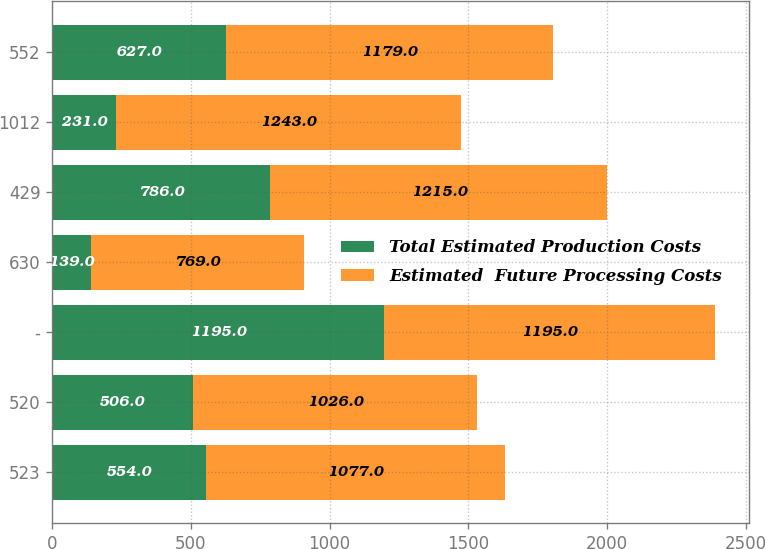<chart> <loc_0><loc_0><loc_500><loc_500><stacked_bar_chart><ecel><fcel>523<fcel>520<fcel>-<fcel>630<fcel>429<fcel>1012<fcel>552<nl><fcel>Total Estimated Production Costs<fcel>554<fcel>506<fcel>1195<fcel>139<fcel>786<fcel>231<fcel>627<nl><fcel>Estimated  Future Processing Costs<fcel>1077<fcel>1026<fcel>1195<fcel>769<fcel>1215<fcel>1243<fcel>1179<nl></chart> 